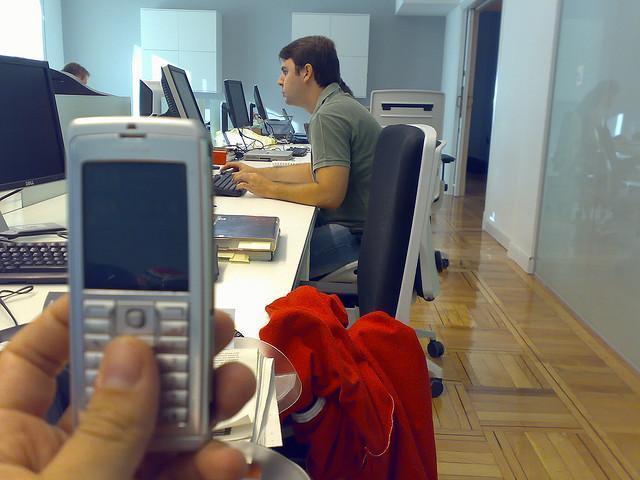How many computer monitors can be seen?
Give a very brief answer. 4. How many people are there?
Give a very brief answer. 2. How many clock faces are visible?
Give a very brief answer. 0. 